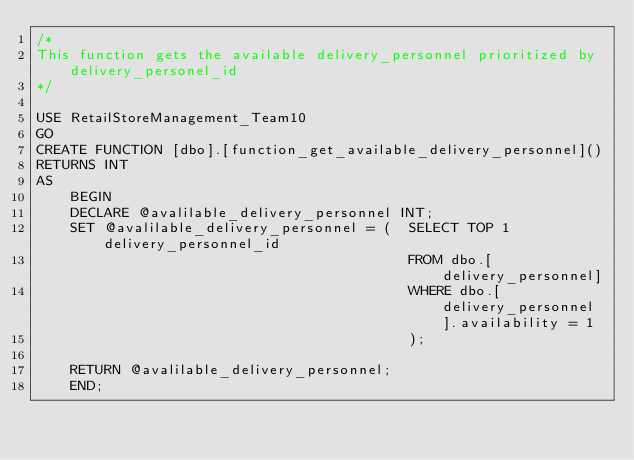<code> <loc_0><loc_0><loc_500><loc_500><_SQL_>/*
This function gets the available delivery_personnel prioritized by delivery_personel_id
*/

USE RetailStoreManagement_Team10
GO
CREATE FUNCTION [dbo].[function_get_available_delivery_personnel]()
RETURNS INT
AS
	BEGIN
	DECLARE @avalilable_delivery_personnel INT;
	SET @avalilable_delivery_personnel = (	SELECT TOP 1 delivery_personnel_id 
											FROM dbo.[delivery_personnel]
											WHERE dbo.[delivery_personnel].availability = 1
											);
		
	RETURN @avalilable_delivery_personnel;
	END;</code> 